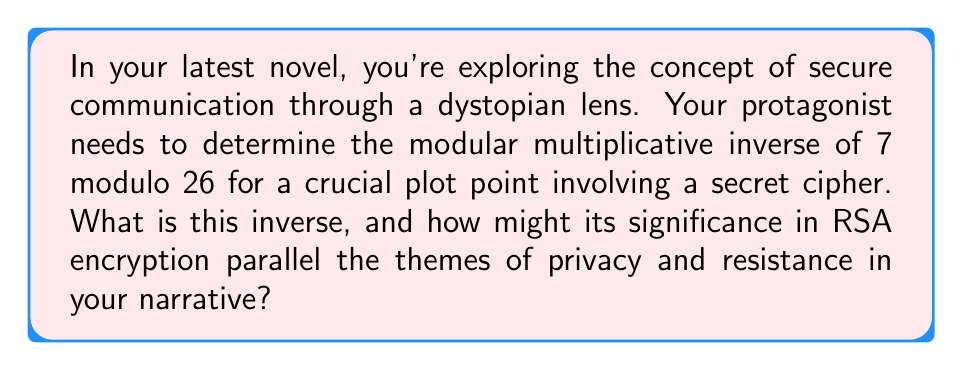Solve this math problem. To find the modular multiplicative inverse of 7 modulo 26, we need to find a number $x$ such that:

$$(7x) \bmod 26 \equiv 1$$

We can use the extended Euclidean algorithm to find this inverse:

1) First, set up the initial equation:
   $$26 = 3 \cdot 7 + 5$$

2) Then, continue the process:
   $$7 = 1 \cdot 5 + 2$$
   $$5 = 2 \cdot 2 + 1$$

3) Now, work backwards to express 1 as a linear combination of 26 and 7:
   $$1 = 5 - 2 \cdot 2$$
   $$1 = 5 - 2 \cdot (7 - 1 \cdot 5) = 3 \cdot 5 - 2 \cdot 7$$
   $$1 = 3 \cdot (26 - 3 \cdot 7) - 2 \cdot 7 = 3 \cdot 26 - 11 \cdot 7$$

4) Therefore, $(-11 \cdot 7) \bmod 26 \equiv 1$

5) To get a positive number between 0 and 25, we add 26 to -11 until we get a positive number in this range:
   $$-11 + 26 = 15$$

Thus, 15 is the modular multiplicative inverse of 7 modulo 26.

In RSA encryption, modular multiplicative inverses are crucial for generating the private key from the public key. This mathematical concept could symbolize the delicate balance between public and private information in your dystopian world, where the protagonist's ability to find this inverse represents their power to maintain privacy and resist oppression.
Answer: 15 